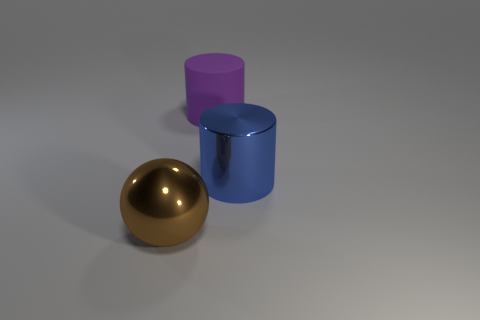Is the color of the large metal cylinder the same as the rubber cylinder?
Your answer should be very brief. No. How many shiny things are left of the large brown shiny object?
Your response must be concise. 0. What number of things are behind the blue metal object and to the left of the large purple matte cylinder?
Provide a short and direct response. 0. There is a big brown thing that is the same material as the large blue thing; what shape is it?
Keep it short and to the point. Sphere. Does the thing in front of the blue metallic cylinder have the same size as the metallic object behind the brown metal object?
Offer a terse response. Yes. What color is the big metal thing that is in front of the big blue shiny cylinder?
Offer a very short reply. Brown. What is the material of the big thing that is behind the large cylinder that is in front of the large rubber thing?
Give a very brief answer. Rubber. The rubber object is what shape?
Give a very brief answer. Cylinder. What is the material of the other big thing that is the same shape as the big rubber thing?
Keep it short and to the point. Metal. How many blue shiny cylinders have the same size as the blue thing?
Provide a short and direct response. 0. 